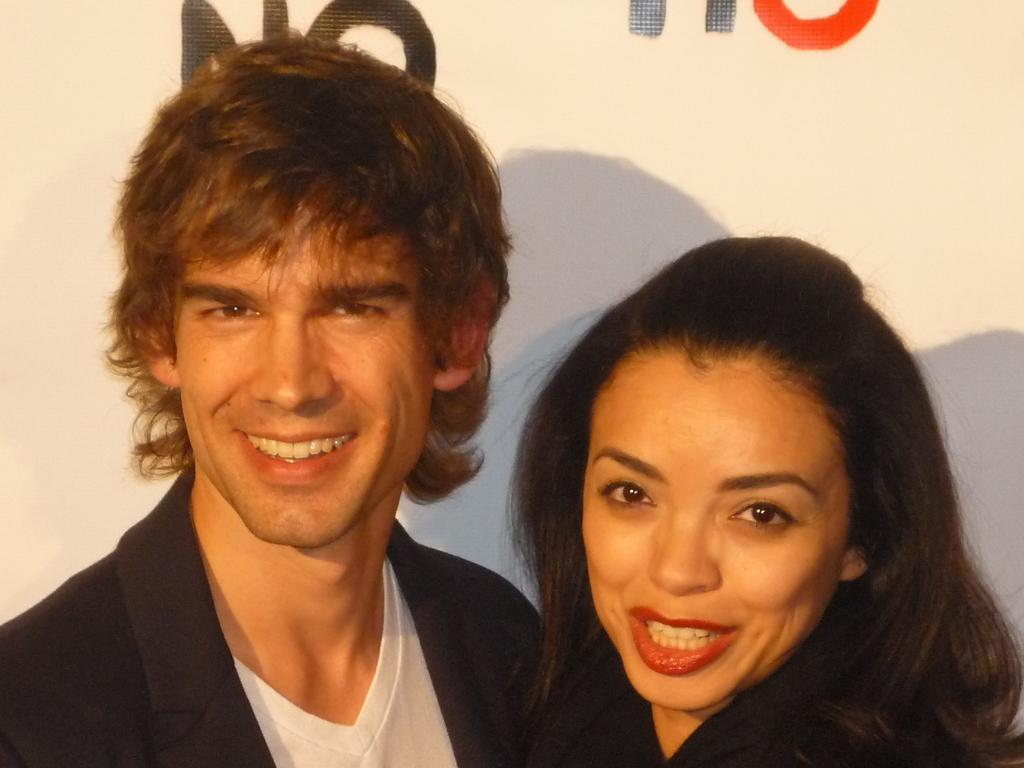Who is present in the image? There is a man and a woman in the image. What are the man and the woman doing in the image? Both the man and the woman are smiling and posing for the picture. Can you describe the text on the white surface at the top of the image? Unfortunately, the provided facts do not mention the content of the text on the white surface. How can you tell that the man and the woman are happy in the image? Both the man and the woman are smiling, which indicates that they are happy. What type of shade is being used by the man in the image? There is no shade present in the image; both the man and the woman are standing in the open. Can you tell me how many elbows the man has in the image? The man has two elbows in the image, as he is a human being with two arms. 